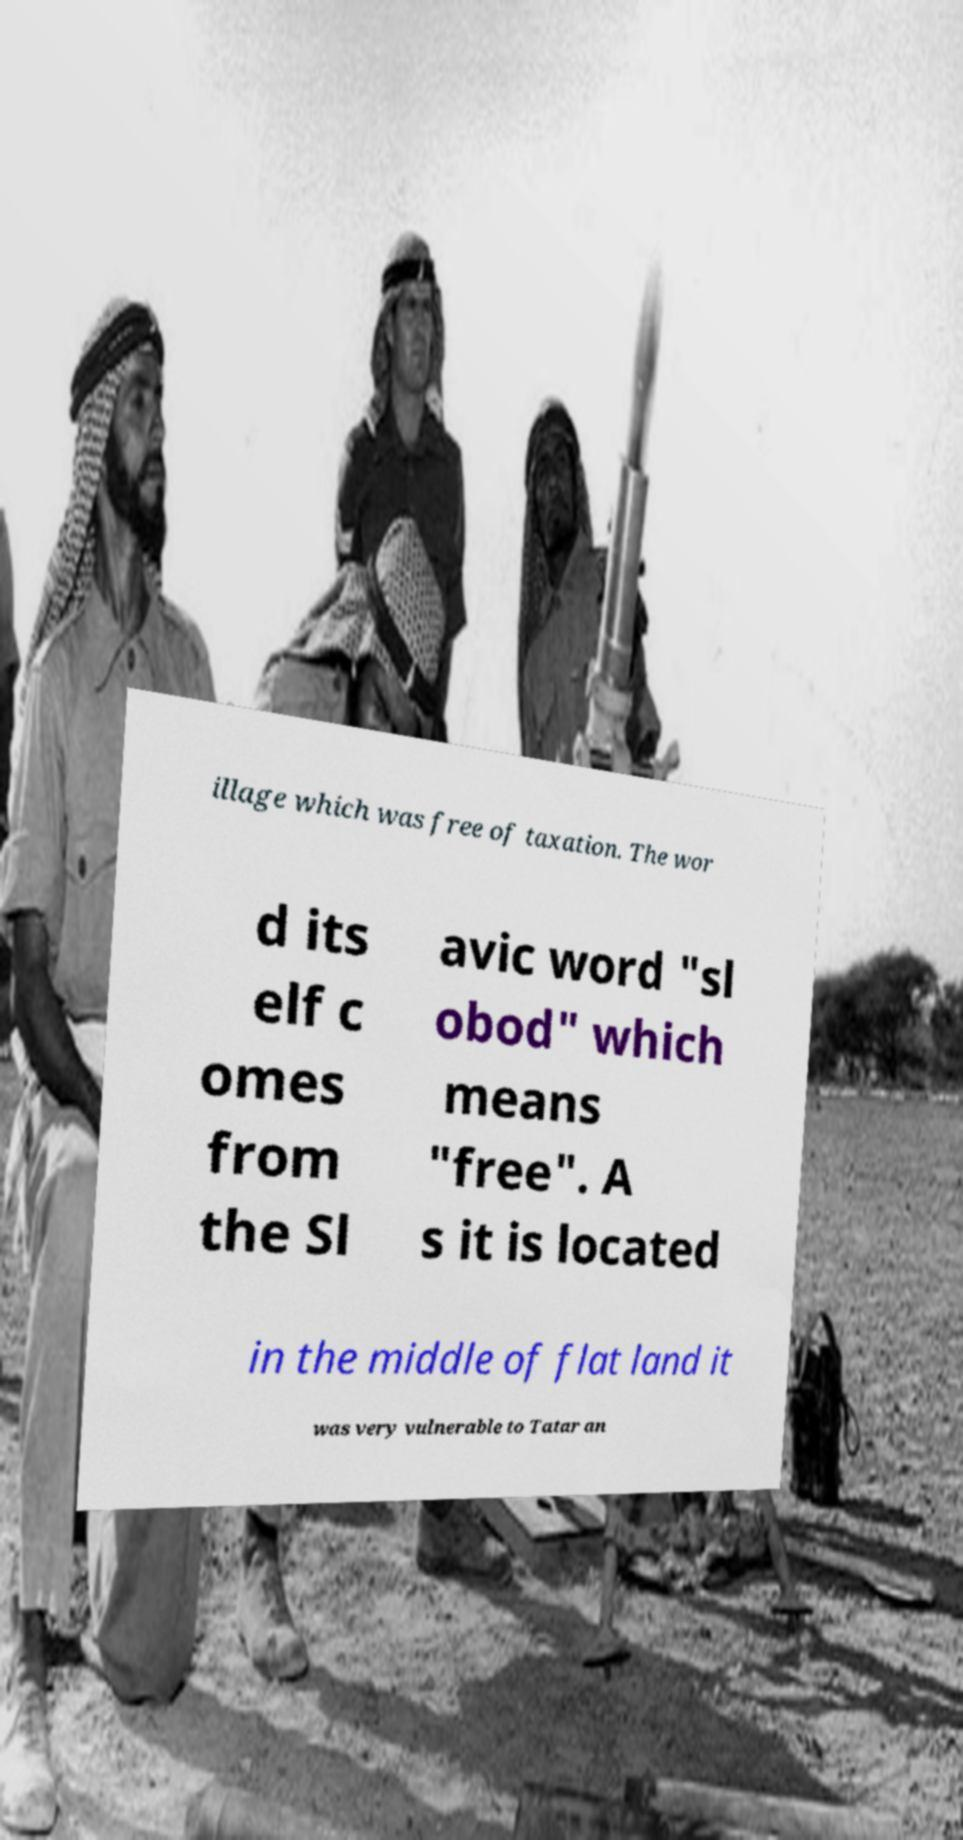Can you accurately transcribe the text from the provided image for me? illage which was free of taxation. The wor d its elf c omes from the Sl avic word "sl obod" which means "free". A s it is located in the middle of flat land it was very vulnerable to Tatar an 